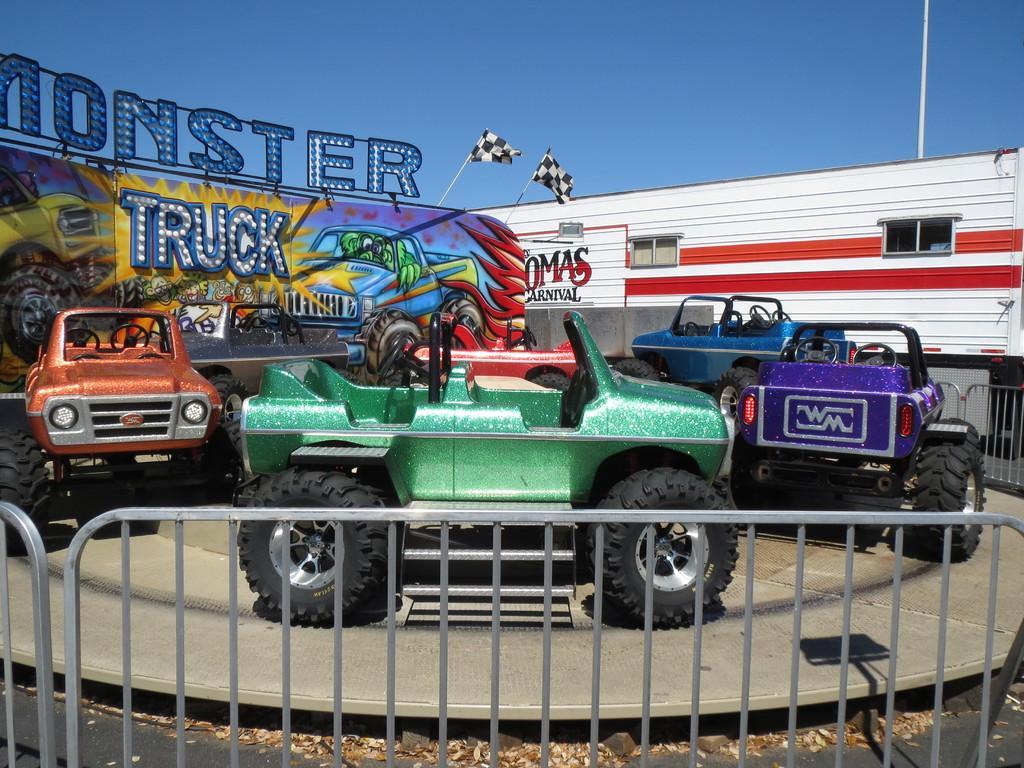Describe this image in one or two sentences. In this image I can see vehicles. There are barriers, flags with poles, boards and in the background there is sky. 